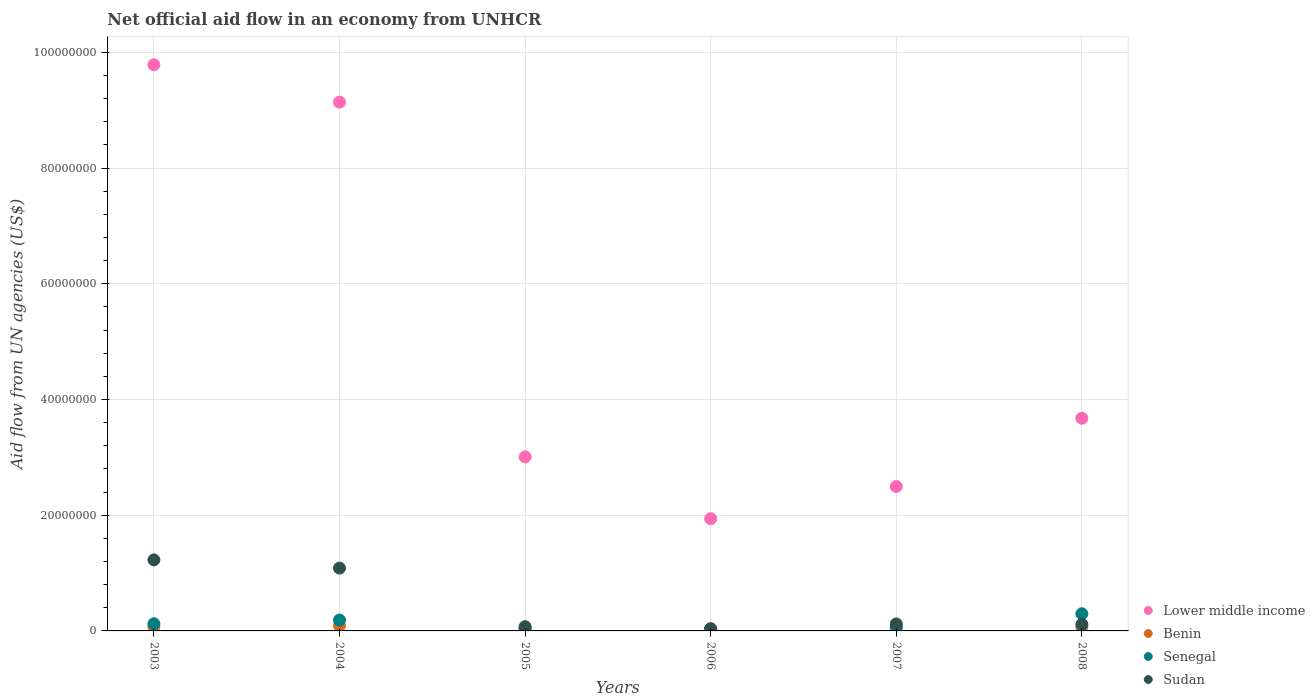What is the net official aid flow in Benin in 2006?
Ensure brevity in your answer.  3.20e+05. Across all years, what is the maximum net official aid flow in Benin?
Your answer should be compact. 9.00e+05. Across all years, what is the minimum net official aid flow in Senegal?
Provide a short and direct response. 2.60e+05. In which year was the net official aid flow in Benin maximum?
Offer a terse response. 2004. What is the total net official aid flow in Sudan in the graph?
Make the answer very short. 2.66e+07. What is the difference between the net official aid flow in Sudan in 2006 and the net official aid flow in Senegal in 2003?
Provide a succinct answer. -8.60e+05. What is the average net official aid flow in Lower middle income per year?
Your response must be concise. 5.01e+07. In the year 2005, what is the difference between the net official aid flow in Senegal and net official aid flow in Sudan?
Give a very brief answer. -2.30e+05. What is the ratio of the net official aid flow in Sudan in 2003 to that in 2006?
Ensure brevity in your answer.  32.32. What is the difference between the highest and the second highest net official aid flow in Lower middle income?
Make the answer very short. 6.45e+06. What is the difference between the highest and the lowest net official aid flow in Benin?
Offer a terse response. 5.80e+05. In how many years, is the net official aid flow in Senegal greater than the average net official aid flow in Senegal taken over all years?
Your answer should be very brief. 2. Is it the case that in every year, the sum of the net official aid flow in Sudan and net official aid flow in Benin  is greater than the sum of net official aid flow in Lower middle income and net official aid flow in Senegal?
Provide a succinct answer. No. Is it the case that in every year, the sum of the net official aid flow in Senegal and net official aid flow in Lower middle income  is greater than the net official aid flow in Benin?
Provide a succinct answer. Yes. Is the net official aid flow in Sudan strictly greater than the net official aid flow in Benin over the years?
Provide a succinct answer. Yes. How many dotlines are there?
Offer a terse response. 4. How many years are there in the graph?
Provide a succinct answer. 6. Are the values on the major ticks of Y-axis written in scientific E-notation?
Keep it short and to the point. No. Does the graph contain any zero values?
Keep it short and to the point. No. Does the graph contain grids?
Offer a very short reply. Yes. Where does the legend appear in the graph?
Offer a very short reply. Bottom right. How many legend labels are there?
Offer a very short reply. 4. What is the title of the graph?
Your answer should be very brief. Net official aid flow in an economy from UNHCR. Does "Malta" appear as one of the legend labels in the graph?
Offer a terse response. No. What is the label or title of the X-axis?
Your answer should be compact. Years. What is the label or title of the Y-axis?
Your answer should be very brief. Aid flow from UN agencies (US$). What is the Aid flow from UN agencies (US$) of Lower middle income in 2003?
Your answer should be very brief. 9.78e+07. What is the Aid flow from UN agencies (US$) of Benin in 2003?
Offer a terse response. 7.50e+05. What is the Aid flow from UN agencies (US$) of Senegal in 2003?
Give a very brief answer. 1.24e+06. What is the Aid flow from UN agencies (US$) of Sudan in 2003?
Make the answer very short. 1.23e+07. What is the Aid flow from UN agencies (US$) in Lower middle income in 2004?
Your answer should be very brief. 9.14e+07. What is the Aid flow from UN agencies (US$) of Senegal in 2004?
Offer a terse response. 1.88e+06. What is the Aid flow from UN agencies (US$) in Sudan in 2004?
Your response must be concise. 1.09e+07. What is the Aid flow from UN agencies (US$) of Lower middle income in 2005?
Make the answer very short. 3.01e+07. What is the Aid flow from UN agencies (US$) of Benin in 2005?
Your response must be concise. 4.30e+05. What is the Aid flow from UN agencies (US$) in Sudan in 2005?
Offer a terse response. 7.30e+05. What is the Aid flow from UN agencies (US$) in Lower middle income in 2006?
Offer a very short reply. 1.94e+07. What is the Aid flow from UN agencies (US$) in Senegal in 2006?
Offer a very short reply. 2.60e+05. What is the Aid flow from UN agencies (US$) in Sudan in 2006?
Provide a short and direct response. 3.80e+05. What is the Aid flow from UN agencies (US$) of Lower middle income in 2007?
Give a very brief answer. 2.50e+07. What is the Aid flow from UN agencies (US$) in Benin in 2007?
Give a very brief answer. 5.80e+05. What is the Aid flow from UN agencies (US$) of Senegal in 2007?
Offer a terse response. 7.00e+05. What is the Aid flow from UN agencies (US$) of Sudan in 2007?
Your answer should be compact. 1.21e+06. What is the Aid flow from UN agencies (US$) of Lower middle income in 2008?
Provide a succinct answer. 3.68e+07. What is the Aid flow from UN agencies (US$) of Benin in 2008?
Your answer should be very brief. 7.40e+05. What is the Aid flow from UN agencies (US$) of Senegal in 2008?
Keep it short and to the point. 2.97e+06. What is the Aid flow from UN agencies (US$) of Sudan in 2008?
Keep it short and to the point. 1.14e+06. Across all years, what is the maximum Aid flow from UN agencies (US$) of Lower middle income?
Offer a terse response. 9.78e+07. Across all years, what is the maximum Aid flow from UN agencies (US$) in Benin?
Keep it short and to the point. 9.00e+05. Across all years, what is the maximum Aid flow from UN agencies (US$) of Senegal?
Your answer should be compact. 2.97e+06. Across all years, what is the maximum Aid flow from UN agencies (US$) in Sudan?
Make the answer very short. 1.23e+07. Across all years, what is the minimum Aid flow from UN agencies (US$) of Lower middle income?
Keep it short and to the point. 1.94e+07. Across all years, what is the minimum Aid flow from UN agencies (US$) in Benin?
Ensure brevity in your answer.  3.20e+05. Across all years, what is the minimum Aid flow from UN agencies (US$) in Senegal?
Give a very brief answer. 2.60e+05. What is the total Aid flow from UN agencies (US$) of Lower middle income in the graph?
Your response must be concise. 3.00e+08. What is the total Aid flow from UN agencies (US$) of Benin in the graph?
Offer a very short reply. 3.72e+06. What is the total Aid flow from UN agencies (US$) of Senegal in the graph?
Provide a short and direct response. 7.55e+06. What is the total Aid flow from UN agencies (US$) of Sudan in the graph?
Make the answer very short. 2.66e+07. What is the difference between the Aid flow from UN agencies (US$) of Lower middle income in 2003 and that in 2004?
Your response must be concise. 6.45e+06. What is the difference between the Aid flow from UN agencies (US$) in Senegal in 2003 and that in 2004?
Your response must be concise. -6.40e+05. What is the difference between the Aid flow from UN agencies (US$) of Sudan in 2003 and that in 2004?
Offer a terse response. 1.42e+06. What is the difference between the Aid flow from UN agencies (US$) in Lower middle income in 2003 and that in 2005?
Provide a succinct answer. 6.78e+07. What is the difference between the Aid flow from UN agencies (US$) of Benin in 2003 and that in 2005?
Your answer should be compact. 3.20e+05. What is the difference between the Aid flow from UN agencies (US$) in Senegal in 2003 and that in 2005?
Your response must be concise. 7.40e+05. What is the difference between the Aid flow from UN agencies (US$) in Sudan in 2003 and that in 2005?
Your answer should be very brief. 1.16e+07. What is the difference between the Aid flow from UN agencies (US$) in Lower middle income in 2003 and that in 2006?
Make the answer very short. 7.84e+07. What is the difference between the Aid flow from UN agencies (US$) of Benin in 2003 and that in 2006?
Make the answer very short. 4.30e+05. What is the difference between the Aid flow from UN agencies (US$) in Senegal in 2003 and that in 2006?
Make the answer very short. 9.80e+05. What is the difference between the Aid flow from UN agencies (US$) in Sudan in 2003 and that in 2006?
Keep it short and to the point. 1.19e+07. What is the difference between the Aid flow from UN agencies (US$) of Lower middle income in 2003 and that in 2007?
Your answer should be compact. 7.29e+07. What is the difference between the Aid flow from UN agencies (US$) of Benin in 2003 and that in 2007?
Keep it short and to the point. 1.70e+05. What is the difference between the Aid flow from UN agencies (US$) in Senegal in 2003 and that in 2007?
Your response must be concise. 5.40e+05. What is the difference between the Aid flow from UN agencies (US$) in Sudan in 2003 and that in 2007?
Your answer should be very brief. 1.11e+07. What is the difference between the Aid flow from UN agencies (US$) in Lower middle income in 2003 and that in 2008?
Provide a succinct answer. 6.11e+07. What is the difference between the Aid flow from UN agencies (US$) of Benin in 2003 and that in 2008?
Make the answer very short. 10000. What is the difference between the Aid flow from UN agencies (US$) of Senegal in 2003 and that in 2008?
Offer a very short reply. -1.73e+06. What is the difference between the Aid flow from UN agencies (US$) of Sudan in 2003 and that in 2008?
Ensure brevity in your answer.  1.11e+07. What is the difference between the Aid flow from UN agencies (US$) of Lower middle income in 2004 and that in 2005?
Your answer should be very brief. 6.13e+07. What is the difference between the Aid flow from UN agencies (US$) in Benin in 2004 and that in 2005?
Give a very brief answer. 4.70e+05. What is the difference between the Aid flow from UN agencies (US$) of Senegal in 2004 and that in 2005?
Provide a short and direct response. 1.38e+06. What is the difference between the Aid flow from UN agencies (US$) in Sudan in 2004 and that in 2005?
Keep it short and to the point. 1.01e+07. What is the difference between the Aid flow from UN agencies (US$) in Lower middle income in 2004 and that in 2006?
Your response must be concise. 7.20e+07. What is the difference between the Aid flow from UN agencies (US$) of Benin in 2004 and that in 2006?
Provide a short and direct response. 5.80e+05. What is the difference between the Aid flow from UN agencies (US$) in Senegal in 2004 and that in 2006?
Ensure brevity in your answer.  1.62e+06. What is the difference between the Aid flow from UN agencies (US$) of Sudan in 2004 and that in 2006?
Your answer should be compact. 1.05e+07. What is the difference between the Aid flow from UN agencies (US$) in Lower middle income in 2004 and that in 2007?
Your response must be concise. 6.64e+07. What is the difference between the Aid flow from UN agencies (US$) in Senegal in 2004 and that in 2007?
Your answer should be compact. 1.18e+06. What is the difference between the Aid flow from UN agencies (US$) in Sudan in 2004 and that in 2007?
Offer a terse response. 9.65e+06. What is the difference between the Aid flow from UN agencies (US$) of Lower middle income in 2004 and that in 2008?
Give a very brief answer. 5.46e+07. What is the difference between the Aid flow from UN agencies (US$) in Senegal in 2004 and that in 2008?
Offer a terse response. -1.09e+06. What is the difference between the Aid flow from UN agencies (US$) in Sudan in 2004 and that in 2008?
Provide a short and direct response. 9.72e+06. What is the difference between the Aid flow from UN agencies (US$) of Lower middle income in 2005 and that in 2006?
Offer a terse response. 1.07e+07. What is the difference between the Aid flow from UN agencies (US$) of Benin in 2005 and that in 2006?
Your answer should be compact. 1.10e+05. What is the difference between the Aid flow from UN agencies (US$) in Lower middle income in 2005 and that in 2007?
Make the answer very short. 5.13e+06. What is the difference between the Aid flow from UN agencies (US$) in Benin in 2005 and that in 2007?
Provide a succinct answer. -1.50e+05. What is the difference between the Aid flow from UN agencies (US$) of Senegal in 2005 and that in 2007?
Provide a succinct answer. -2.00e+05. What is the difference between the Aid flow from UN agencies (US$) in Sudan in 2005 and that in 2007?
Your answer should be compact. -4.80e+05. What is the difference between the Aid flow from UN agencies (US$) in Lower middle income in 2005 and that in 2008?
Your response must be concise. -6.67e+06. What is the difference between the Aid flow from UN agencies (US$) of Benin in 2005 and that in 2008?
Your response must be concise. -3.10e+05. What is the difference between the Aid flow from UN agencies (US$) of Senegal in 2005 and that in 2008?
Offer a very short reply. -2.47e+06. What is the difference between the Aid flow from UN agencies (US$) in Sudan in 2005 and that in 2008?
Your answer should be compact. -4.10e+05. What is the difference between the Aid flow from UN agencies (US$) in Lower middle income in 2006 and that in 2007?
Your response must be concise. -5.56e+06. What is the difference between the Aid flow from UN agencies (US$) of Senegal in 2006 and that in 2007?
Offer a very short reply. -4.40e+05. What is the difference between the Aid flow from UN agencies (US$) of Sudan in 2006 and that in 2007?
Your response must be concise. -8.30e+05. What is the difference between the Aid flow from UN agencies (US$) of Lower middle income in 2006 and that in 2008?
Your response must be concise. -1.74e+07. What is the difference between the Aid flow from UN agencies (US$) of Benin in 2006 and that in 2008?
Make the answer very short. -4.20e+05. What is the difference between the Aid flow from UN agencies (US$) in Senegal in 2006 and that in 2008?
Your answer should be compact. -2.71e+06. What is the difference between the Aid flow from UN agencies (US$) of Sudan in 2006 and that in 2008?
Offer a very short reply. -7.60e+05. What is the difference between the Aid flow from UN agencies (US$) in Lower middle income in 2007 and that in 2008?
Provide a succinct answer. -1.18e+07. What is the difference between the Aid flow from UN agencies (US$) in Senegal in 2007 and that in 2008?
Make the answer very short. -2.27e+06. What is the difference between the Aid flow from UN agencies (US$) of Sudan in 2007 and that in 2008?
Ensure brevity in your answer.  7.00e+04. What is the difference between the Aid flow from UN agencies (US$) in Lower middle income in 2003 and the Aid flow from UN agencies (US$) in Benin in 2004?
Offer a terse response. 9.70e+07. What is the difference between the Aid flow from UN agencies (US$) in Lower middle income in 2003 and the Aid flow from UN agencies (US$) in Senegal in 2004?
Offer a very short reply. 9.60e+07. What is the difference between the Aid flow from UN agencies (US$) of Lower middle income in 2003 and the Aid flow from UN agencies (US$) of Sudan in 2004?
Offer a very short reply. 8.70e+07. What is the difference between the Aid flow from UN agencies (US$) of Benin in 2003 and the Aid flow from UN agencies (US$) of Senegal in 2004?
Your response must be concise. -1.13e+06. What is the difference between the Aid flow from UN agencies (US$) in Benin in 2003 and the Aid flow from UN agencies (US$) in Sudan in 2004?
Provide a succinct answer. -1.01e+07. What is the difference between the Aid flow from UN agencies (US$) of Senegal in 2003 and the Aid flow from UN agencies (US$) of Sudan in 2004?
Your answer should be very brief. -9.62e+06. What is the difference between the Aid flow from UN agencies (US$) of Lower middle income in 2003 and the Aid flow from UN agencies (US$) of Benin in 2005?
Ensure brevity in your answer.  9.74e+07. What is the difference between the Aid flow from UN agencies (US$) in Lower middle income in 2003 and the Aid flow from UN agencies (US$) in Senegal in 2005?
Give a very brief answer. 9.74e+07. What is the difference between the Aid flow from UN agencies (US$) in Lower middle income in 2003 and the Aid flow from UN agencies (US$) in Sudan in 2005?
Ensure brevity in your answer.  9.71e+07. What is the difference between the Aid flow from UN agencies (US$) of Benin in 2003 and the Aid flow from UN agencies (US$) of Senegal in 2005?
Make the answer very short. 2.50e+05. What is the difference between the Aid flow from UN agencies (US$) of Senegal in 2003 and the Aid flow from UN agencies (US$) of Sudan in 2005?
Make the answer very short. 5.10e+05. What is the difference between the Aid flow from UN agencies (US$) in Lower middle income in 2003 and the Aid flow from UN agencies (US$) in Benin in 2006?
Ensure brevity in your answer.  9.75e+07. What is the difference between the Aid flow from UN agencies (US$) of Lower middle income in 2003 and the Aid flow from UN agencies (US$) of Senegal in 2006?
Make the answer very short. 9.76e+07. What is the difference between the Aid flow from UN agencies (US$) of Lower middle income in 2003 and the Aid flow from UN agencies (US$) of Sudan in 2006?
Provide a succinct answer. 9.75e+07. What is the difference between the Aid flow from UN agencies (US$) of Benin in 2003 and the Aid flow from UN agencies (US$) of Senegal in 2006?
Give a very brief answer. 4.90e+05. What is the difference between the Aid flow from UN agencies (US$) in Benin in 2003 and the Aid flow from UN agencies (US$) in Sudan in 2006?
Provide a succinct answer. 3.70e+05. What is the difference between the Aid flow from UN agencies (US$) of Senegal in 2003 and the Aid flow from UN agencies (US$) of Sudan in 2006?
Provide a succinct answer. 8.60e+05. What is the difference between the Aid flow from UN agencies (US$) of Lower middle income in 2003 and the Aid flow from UN agencies (US$) of Benin in 2007?
Your answer should be compact. 9.73e+07. What is the difference between the Aid flow from UN agencies (US$) of Lower middle income in 2003 and the Aid flow from UN agencies (US$) of Senegal in 2007?
Provide a succinct answer. 9.72e+07. What is the difference between the Aid flow from UN agencies (US$) of Lower middle income in 2003 and the Aid flow from UN agencies (US$) of Sudan in 2007?
Your response must be concise. 9.66e+07. What is the difference between the Aid flow from UN agencies (US$) in Benin in 2003 and the Aid flow from UN agencies (US$) in Sudan in 2007?
Make the answer very short. -4.60e+05. What is the difference between the Aid flow from UN agencies (US$) of Senegal in 2003 and the Aid flow from UN agencies (US$) of Sudan in 2007?
Your answer should be compact. 3.00e+04. What is the difference between the Aid flow from UN agencies (US$) of Lower middle income in 2003 and the Aid flow from UN agencies (US$) of Benin in 2008?
Give a very brief answer. 9.71e+07. What is the difference between the Aid flow from UN agencies (US$) of Lower middle income in 2003 and the Aid flow from UN agencies (US$) of Senegal in 2008?
Ensure brevity in your answer.  9.49e+07. What is the difference between the Aid flow from UN agencies (US$) of Lower middle income in 2003 and the Aid flow from UN agencies (US$) of Sudan in 2008?
Make the answer very short. 9.67e+07. What is the difference between the Aid flow from UN agencies (US$) of Benin in 2003 and the Aid flow from UN agencies (US$) of Senegal in 2008?
Offer a terse response. -2.22e+06. What is the difference between the Aid flow from UN agencies (US$) of Benin in 2003 and the Aid flow from UN agencies (US$) of Sudan in 2008?
Your response must be concise. -3.90e+05. What is the difference between the Aid flow from UN agencies (US$) of Senegal in 2003 and the Aid flow from UN agencies (US$) of Sudan in 2008?
Your response must be concise. 1.00e+05. What is the difference between the Aid flow from UN agencies (US$) of Lower middle income in 2004 and the Aid flow from UN agencies (US$) of Benin in 2005?
Your answer should be very brief. 9.10e+07. What is the difference between the Aid flow from UN agencies (US$) of Lower middle income in 2004 and the Aid flow from UN agencies (US$) of Senegal in 2005?
Keep it short and to the point. 9.09e+07. What is the difference between the Aid flow from UN agencies (US$) of Lower middle income in 2004 and the Aid flow from UN agencies (US$) of Sudan in 2005?
Give a very brief answer. 9.07e+07. What is the difference between the Aid flow from UN agencies (US$) of Benin in 2004 and the Aid flow from UN agencies (US$) of Sudan in 2005?
Provide a succinct answer. 1.70e+05. What is the difference between the Aid flow from UN agencies (US$) in Senegal in 2004 and the Aid flow from UN agencies (US$) in Sudan in 2005?
Your response must be concise. 1.15e+06. What is the difference between the Aid flow from UN agencies (US$) of Lower middle income in 2004 and the Aid flow from UN agencies (US$) of Benin in 2006?
Your answer should be very brief. 9.11e+07. What is the difference between the Aid flow from UN agencies (US$) in Lower middle income in 2004 and the Aid flow from UN agencies (US$) in Senegal in 2006?
Ensure brevity in your answer.  9.11e+07. What is the difference between the Aid flow from UN agencies (US$) of Lower middle income in 2004 and the Aid flow from UN agencies (US$) of Sudan in 2006?
Provide a succinct answer. 9.10e+07. What is the difference between the Aid flow from UN agencies (US$) of Benin in 2004 and the Aid flow from UN agencies (US$) of Senegal in 2006?
Your response must be concise. 6.40e+05. What is the difference between the Aid flow from UN agencies (US$) of Benin in 2004 and the Aid flow from UN agencies (US$) of Sudan in 2006?
Your answer should be very brief. 5.20e+05. What is the difference between the Aid flow from UN agencies (US$) of Senegal in 2004 and the Aid flow from UN agencies (US$) of Sudan in 2006?
Provide a succinct answer. 1.50e+06. What is the difference between the Aid flow from UN agencies (US$) in Lower middle income in 2004 and the Aid flow from UN agencies (US$) in Benin in 2007?
Offer a terse response. 9.08e+07. What is the difference between the Aid flow from UN agencies (US$) of Lower middle income in 2004 and the Aid flow from UN agencies (US$) of Senegal in 2007?
Provide a succinct answer. 9.07e+07. What is the difference between the Aid flow from UN agencies (US$) in Lower middle income in 2004 and the Aid flow from UN agencies (US$) in Sudan in 2007?
Keep it short and to the point. 9.02e+07. What is the difference between the Aid flow from UN agencies (US$) in Benin in 2004 and the Aid flow from UN agencies (US$) in Senegal in 2007?
Make the answer very short. 2.00e+05. What is the difference between the Aid flow from UN agencies (US$) in Benin in 2004 and the Aid flow from UN agencies (US$) in Sudan in 2007?
Your answer should be compact. -3.10e+05. What is the difference between the Aid flow from UN agencies (US$) of Senegal in 2004 and the Aid flow from UN agencies (US$) of Sudan in 2007?
Your answer should be compact. 6.70e+05. What is the difference between the Aid flow from UN agencies (US$) in Lower middle income in 2004 and the Aid flow from UN agencies (US$) in Benin in 2008?
Provide a succinct answer. 9.07e+07. What is the difference between the Aid flow from UN agencies (US$) of Lower middle income in 2004 and the Aid flow from UN agencies (US$) of Senegal in 2008?
Keep it short and to the point. 8.84e+07. What is the difference between the Aid flow from UN agencies (US$) in Lower middle income in 2004 and the Aid flow from UN agencies (US$) in Sudan in 2008?
Keep it short and to the point. 9.03e+07. What is the difference between the Aid flow from UN agencies (US$) of Benin in 2004 and the Aid flow from UN agencies (US$) of Senegal in 2008?
Offer a terse response. -2.07e+06. What is the difference between the Aid flow from UN agencies (US$) in Benin in 2004 and the Aid flow from UN agencies (US$) in Sudan in 2008?
Provide a short and direct response. -2.40e+05. What is the difference between the Aid flow from UN agencies (US$) in Senegal in 2004 and the Aid flow from UN agencies (US$) in Sudan in 2008?
Offer a very short reply. 7.40e+05. What is the difference between the Aid flow from UN agencies (US$) of Lower middle income in 2005 and the Aid flow from UN agencies (US$) of Benin in 2006?
Your answer should be compact. 2.98e+07. What is the difference between the Aid flow from UN agencies (US$) in Lower middle income in 2005 and the Aid flow from UN agencies (US$) in Senegal in 2006?
Give a very brief answer. 2.98e+07. What is the difference between the Aid flow from UN agencies (US$) of Lower middle income in 2005 and the Aid flow from UN agencies (US$) of Sudan in 2006?
Your response must be concise. 2.97e+07. What is the difference between the Aid flow from UN agencies (US$) of Benin in 2005 and the Aid flow from UN agencies (US$) of Sudan in 2006?
Your answer should be compact. 5.00e+04. What is the difference between the Aid flow from UN agencies (US$) in Lower middle income in 2005 and the Aid flow from UN agencies (US$) in Benin in 2007?
Provide a short and direct response. 2.95e+07. What is the difference between the Aid flow from UN agencies (US$) in Lower middle income in 2005 and the Aid flow from UN agencies (US$) in Senegal in 2007?
Your response must be concise. 2.94e+07. What is the difference between the Aid flow from UN agencies (US$) in Lower middle income in 2005 and the Aid flow from UN agencies (US$) in Sudan in 2007?
Your answer should be very brief. 2.89e+07. What is the difference between the Aid flow from UN agencies (US$) in Benin in 2005 and the Aid flow from UN agencies (US$) in Sudan in 2007?
Offer a terse response. -7.80e+05. What is the difference between the Aid flow from UN agencies (US$) in Senegal in 2005 and the Aid flow from UN agencies (US$) in Sudan in 2007?
Provide a short and direct response. -7.10e+05. What is the difference between the Aid flow from UN agencies (US$) of Lower middle income in 2005 and the Aid flow from UN agencies (US$) of Benin in 2008?
Offer a terse response. 2.94e+07. What is the difference between the Aid flow from UN agencies (US$) of Lower middle income in 2005 and the Aid flow from UN agencies (US$) of Senegal in 2008?
Offer a terse response. 2.71e+07. What is the difference between the Aid flow from UN agencies (US$) in Lower middle income in 2005 and the Aid flow from UN agencies (US$) in Sudan in 2008?
Your answer should be very brief. 2.90e+07. What is the difference between the Aid flow from UN agencies (US$) of Benin in 2005 and the Aid flow from UN agencies (US$) of Senegal in 2008?
Give a very brief answer. -2.54e+06. What is the difference between the Aid flow from UN agencies (US$) in Benin in 2005 and the Aid flow from UN agencies (US$) in Sudan in 2008?
Ensure brevity in your answer.  -7.10e+05. What is the difference between the Aid flow from UN agencies (US$) of Senegal in 2005 and the Aid flow from UN agencies (US$) of Sudan in 2008?
Your answer should be very brief. -6.40e+05. What is the difference between the Aid flow from UN agencies (US$) in Lower middle income in 2006 and the Aid flow from UN agencies (US$) in Benin in 2007?
Keep it short and to the point. 1.88e+07. What is the difference between the Aid flow from UN agencies (US$) in Lower middle income in 2006 and the Aid flow from UN agencies (US$) in Senegal in 2007?
Ensure brevity in your answer.  1.87e+07. What is the difference between the Aid flow from UN agencies (US$) in Lower middle income in 2006 and the Aid flow from UN agencies (US$) in Sudan in 2007?
Your answer should be compact. 1.82e+07. What is the difference between the Aid flow from UN agencies (US$) in Benin in 2006 and the Aid flow from UN agencies (US$) in Senegal in 2007?
Keep it short and to the point. -3.80e+05. What is the difference between the Aid flow from UN agencies (US$) in Benin in 2006 and the Aid flow from UN agencies (US$) in Sudan in 2007?
Offer a very short reply. -8.90e+05. What is the difference between the Aid flow from UN agencies (US$) of Senegal in 2006 and the Aid flow from UN agencies (US$) of Sudan in 2007?
Your response must be concise. -9.50e+05. What is the difference between the Aid flow from UN agencies (US$) of Lower middle income in 2006 and the Aid flow from UN agencies (US$) of Benin in 2008?
Give a very brief answer. 1.87e+07. What is the difference between the Aid flow from UN agencies (US$) in Lower middle income in 2006 and the Aid flow from UN agencies (US$) in Senegal in 2008?
Provide a short and direct response. 1.64e+07. What is the difference between the Aid flow from UN agencies (US$) in Lower middle income in 2006 and the Aid flow from UN agencies (US$) in Sudan in 2008?
Your answer should be very brief. 1.83e+07. What is the difference between the Aid flow from UN agencies (US$) of Benin in 2006 and the Aid flow from UN agencies (US$) of Senegal in 2008?
Give a very brief answer. -2.65e+06. What is the difference between the Aid flow from UN agencies (US$) of Benin in 2006 and the Aid flow from UN agencies (US$) of Sudan in 2008?
Your answer should be compact. -8.20e+05. What is the difference between the Aid flow from UN agencies (US$) in Senegal in 2006 and the Aid flow from UN agencies (US$) in Sudan in 2008?
Your answer should be compact. -8.80e+05. What is the difference between the Aid flow from UN agencies (US$) in Lower middle income in 2007 and the Aid flow from UN agencies (US$) in Benin in 2008?
Give a very brief answer. 2.42e+07. What is the difference between the Aid flow from UN agencies (US$) of Lower middle income in 2007 and the Aid flow from UN agencies (US$) of Senegal in 2008?
Provide a succinct answer. 2.20e+07. What is the difference between the Aid flow from UN agencies (US$) of Lower middle income in 2007 and the Aid flow from UN agencies (US$) of Sudan in 2008?
Offer a terse response. 2.38e+07. What is the difference between the Aid flow from UN agencies (US$) in Benin in 2007 and the Aid flow from UN agencies (US$) in Senegal in 2008?
Provide a succinct answer. -2.39e+06. What is the difference between the Aid flow from UN agencies (US$) in Benin in 2007 and the Aid flow from UN agencies (US$) in Sudan in 2008?
Make the answer very short. -5.60e+05. What is the difference between the Aid flow from UN agencies (US$) in Senegal in 2007 and the Aid flow from UN agencies (US$) in Sudan in 2008?
Offer a terse response. -4.40e+05. What is the average Aid flow from UN agencies (US$) in Lower middle income per year?
Your response must be concise. 5.01e+07. What is the average Aid flow from UN agencies (US$) of Benin per year?
Provide a succinct answer. 6.20e+05. What is the average Aid flow from UN agencies (US$) in Senegal per year?
Offer a terse response. 1.26e+06. What is the average Aid flow from UN agencies (US$) in Sudan per year?
Ensure brevity in your answer.  4.43e+06. In the year 2003, what is the difference between the Aid flow from UN agencies (US$) in Lower middle income and Aid flow from UN agencies (US$) in Benin?
Your response must be concise. 9.71e+07. In the year 2003, what is the difference between the Aid flow from UN agencies (US$) of Lower middle income and Aid flow from UN agencies (US$) of Senegal?
Your answer should be compact. 9.66e+07. In the year 2003, what is the difference between the Aid flow from UN agencies (US$) in Lower middle income and Aid flow from UN agencies (US$) in Sudan?
Offer a terse response. 8.56e+07. In the year 2003, what is the difference between the Aid flow from UN agencies (US$) of Benin and Aid flow from UN agencies (US$) of Senegal?
Your response must be concise. -4.90e+05. In the year 2003, what is the difference between the Aid flow from UN agencies (US$) of Benin and Aid flow from UN agencies (US$) of Sudan?
Offer a terse response. -1.15e+07. In the year 2003, what is the difference between the Aid flow from UN agencies (US$) in Senegal and Aid flow from UN agencies (US$) in Sudan?
Your response must be concise. -1.10e+07. In the year 2004, what is the difference between the Aid flow from UN agencies (US$) of Lower middle income and Aid flow from UN agencies (US$) of Benin?
Your response must be concise. 9.05e+07. In the year 2004, what is the difference between the Aid flow from UN agencies (US$) of Lower middle income and Aid flow from UN agencies (US$) of Senegal?
Make the answer very short. 8.95e+07. In the year 2004, what is the difference between the Aid flow from UN agencies (US$) in Lower middle income and Aid flow from UN agencies (US$) in Sudan?
Provide a succinct answer. 8.05e+07. In the year 2004, what is the difference between the Aid flow from UN agencies (US$) in Benin and Aid flow from UN agencies (US$) in Senegal?
Make the answer very short. -9.80e+05. In the year 2004, what is the difference between the Aid flow from UN agencies (US$) in Benin and Aid flow from UN agencies (US$) in Sudan?
Keep it short and to the point. -9.96e+06. In the year 2004, what is the difference between the Aid flow from UN agencies (US$) of Senegal and Aid flow from UN agencies (US$) of Sudan?
Provide a succinct answer. -8.98e+06. In the year 2005, what is the difference between the Aid flow from UN agencies (US$) in Lower middle income and Aid flow from UN agencies (US$) in Benin?
Offer a very short reply. 2.97e+07. In the year 2005, what is the difference between the Aid flow from UN agencies (US$) of Lower middle income and Aid flow from UN agencies (US$) of Senegal?
Your response must be concise. 2.96e+07. In the year 2005, what is the difference between the Aid flow from UN agencies (US$) of Lower middle income and Aid flow from UN agencies (US$) of Sudan?
Offer a terse response. 2.94e+07. In the year 2005, what is the difference between the Aid flow from UN agencies (US$) in Benin and Aid flow from UN agencies (US$) in Senegal?
Your answer should be compact. -7.00e+04. In the year 2005, what is the difference between the Aid flow from UN agencies (US$) in Benin and Aid flow from UN agencies (US$) in Sudan?
Give a very brief answer. -3.00e+05. In the year 2006, what is the difference between the Aid flow from UN agencies (US$) of Lower middle income and Aid flow from UN agencies (US$) of Benin?
Make the answer very short. 1.91e+07. In the year 2006, what is the difference between the Aid flow from UN agencies (US$) of Lower middle income and Aid flow from UN agencies (US$) of Senegal?
Your answer should be very brief. 1.91e+07. In the year 2006, what is the difference between the Aid flow from UN agencies (US$) of Lower middle income and Aid flow from UN agencies (US$) of Sudan?
Provide a short and direct response. 1.90e+07. In the year 2006, what is the difference between the Aid flow from UN agencies (US$) in Benin and Aid flow from UN agencies (US$) in Sudan?
Provide a succinct answer. -6.00e+04. In the year 2006, what is the difference between the Aid flow from UN agencies (US$) of Senegal and Aid flow from UN agencies (US$) of Sudan?
Your answer should be very brief. -1.20e+05. In the year 2007, what is the difference between the Aid flow from UN agencies (US$) of Lower middle income and Aid flow from UN agencies (US$) of Benin?
Offer a terse response. 2.44e+07. In the year 2007, what is the difference between the Aid flow from UN agencies (US$) in Lower middle income and Aid flow from UN agencies (US$) in Senegal?
Offer a very short reply. 2.43e+07. In the year 2007, what is the difference between the Aid flow from UN agencies (US$) of Lower middle income and Aid flow from UN agencies (US$) of Sudan?
Provide a succinct answer. 2.38e+07. In the year 2007, what is the difference between the Aid flow from UN agencies (US$) of Benin and Aid flow from UN agencies (US$) of Senegal?
Your response must be concise. -1.20e+05. In the year 2007, what is the difference between the Aid flow from UN agencies (US$) of Benin and Aid flow from UN agencies (US$) of Sudan?
Your answer should be compact. -6.30e+05. In the year 2007, what is the difference between the Aid flow from UN agencies (US$) of Senegal and Aid flow from UN agencies (US$) of Sudan?
Make the answer very short. -5.10e+05. In the year 2008, what is the difference between the Aid flow from UN agencies (US$) of Lower middle income and Aid flow from UN agencies (US$) of Benin?
Your answer should be compact. 3.60e+07. In the year 2008, what is the difference between the Aid flow from UN agencies (US$) of Lower middle income and Aid flow from UN agencies (US$) of Senegal?
Provide a succinct answer. 3.38e+07. In the year 2008, what is the difference between the Aid flow from UN agencies (US$) of Lower middle income and Aid flow from UN agencies (US$) of Sudan?
Your response must be concise. 3.56e+07. In the year 2008, what is the difference between the Aid flow from UN agencies (US$) in Benin and Aid flow from UN agencies (US$) in Senegal?
Ensure brevity in your answer.  -2.23e+06. In the year 2008, what is the difference between the Aid flow from UN agencies (US$) of Benin and Aid flow from UN agencies (US$) of Sudan?
Your response must be concise. -4.00e+05. In the year 2008, what is the difference between the Aid flow from UN agencies (US$) of Senegal and Aid flow from UN agencies (US$) of Sudan?
Keep it short and to the point. 1.83e+06. What is the ratio of the Aid flow from UN agencies (US$) in Lower middle income in 2003 to that in 2004?
Your answer should be very brief. 1.07. What is the ratio of the Aid flow from UN agencies (US$) of Benin in 2003 to that in 2004?
Offer a terse response. 0.83. What is the ratio of the Aid flow from UN agencies (US$) in Senegal in 2003 to that in 2004?
Your answer should be compact. 0.66. What is the ratio of the Aid flow from UN agencies (US$) of Sudan in 2003 to that in 2004?
Offer a very short reply. 1.13. What is the ratio of the Aid flow from UN agencies (US$) in Lower middle income in 2003 to that in 2005?
Your response must be concise. 3.25. What is the ratio of the Aid flow from UN agencies (US$) in Benin in 2003 to that in 2005?
Provide a short and direct response. 1.74. What is the ratio of the Aid flow from UN agencies (US$) in Senegal in 2003 to that in 2005?
Make the answer very short. 2.48. What is the ratio of the Aid flow from UN agencies (US$) of Sudan in 2003 to that in 2005?
Provide a succinct answer. 16.82. What is the ratio of the Aid flow from UN agencies (US$) in Lower middle income in 2003 to that in 2006?
Your response must be concise. 5.04. What is the ratio of the Aid flow from UN agencies (US$) in Benin in 2003 to that in 2006?
Offer a very short reply. 2.34. What is the ratio of the Aid flow from UN agencies (US$) of Senegal in 2003 to that in 2006?
Provide a succinct answer. 4.77. What is the ratio of the Aid flow from UN agencies (US$) of Sudan in 2003 to that in 2006?
Your response must be concise. 32.32. What is the ratio of the Aid flow from UN agencies (US$) in Lower middle income in 2003 to that in 2007?
Your answer should be very brief. 3.92. What is the ratio of the Aid flow from UN agencies (US$) in Benin in 2003 to that in 2007?
Your answer should be compact. 1.29. What is the ratio of the Aid flow from UN agencies (US$) in Senegal in 2003 to that in 2007?
Your answer should be compact. 1.77. What is the ratio of the Aid flow from UN agencies (US$) in Sudan in 2003 to that in 2007?
Provide a short and direct response. 10.15. What is the ratio of the Aid flow from UN agencies (US$) of Lower middle income in 2003 to that in 2008?
Keep it short and to the point. 2.66. What is the ratio of the Aid flow from UN agencies (US$) of Benin in 2003 to that in 2008?
Offer a very short reply. 1.01. What is the ratio of the Aid flow from UN agencies (US$) in Senegal in 2003 to that in 2008?
Your answer should be compact. 0.42. What is the ratio of the Aid flow from UN agencies (US$) of Sudan in 2003 to that in 2008?
Provide a succinct answer. 10.77. What is the ratio of the Aid flow from UN agencies (US$) of Lower middle income in 2004 to that in 2005?
Offer a very short reply. 3.04. What is the ratio of the Aid flow from UN agencies (US$) in Benin in 2004 to that in 2005?
Offer a terse response. 2.09. What is the ratio of the Aid flow from UN agencies (US$) of Senegal in 2004 to that in 2005?
Your answer should be compact. 3.76. What is the ratio of the Aid flow from UN agencies (US$) of Sudan in 2004 to that in 2005?
Give a very brief answer. 14.88. What is the ratio of the Aid flow from UN agencies (US$) of Lower middle income in 2004 to that in 2006?
Your response must be concise. 4.71. What is the ratio of the Aid flow from UN agencies (US$) in Benin in 2004 to that in 2006?
Provide a short and direct response. 2.81. What is the ratio of the Aid flow from UN agencies (US$) of Senegal in 2004 to that in 2006?
Your answer should be compact. 7.23. What is the ratio of the Aid flow from UN agencies (US$) of Sudan in 2004 to that in 2006?
Your answer should be very brief. 28.58. What is the ratio of the Aid flow from UN agencies (US$) of Lower middle income in 2004 to that in 2007?
Provide a short and direct response. 3.66. What is the ratio of the Aid flow from UN agencies (US$) of Benin in 2004 to that in 2007?
Keep it short and to the point. 1.55. What is the ratio of the Aid flow from UN agencies (US$) in Senegal in 2004 to that in 2007?
Give a very brief answer. 2.69. What is the ratio of the Aid flow from UN agencies (US$) in Sudan in 2004 to that in 2007?
Your answer should be very brief. 8.98. What is the ratio of the Aid flow from UN agencies (US$) of Lower middle income in 2004 to that in 2008?
Your response must be concise. 2.49. What is the ratio of the Aid flow from UN agencies (US$) of Benin in 2004 to that in 2008?
Provide a short and direct response. 1.22. What is the ratio of the Aid flow from UN agencies (US$) in Senegal in 2004 to that in 2008?
Ensure brevity in your answer.  0.63. What is the ratio of the Aid flow from UN agencies (US$) of Sudan in 2004 to that in 2008?
Your response must be concise. 9.53. What is the ratio of the Aid flow from UN agencies (US$) of Lower middle income in 2005 to that in 2006?
Offer a terse response. 1.55. What is the ratio of the Aid flow from UN agencies (US$) of Benin in 2005 to that in 2006?
Provide a short and direct response. 1.34. What is the ratio of the Aid flow from UN agencies (US$) of Senegal in 2005 to that in 2006?
Ensure brevity in your answer.  1.92. What is the ratio of the Aid flow from UN agencies (US$) of Sudan in 2005 to that in 2006?
Provide a succinct answer. 1.92. What is the ratio of the Aid flow from UN agencies (US$) of Lower middle income in 2005 to that in 2007?
Your response must be concise. 1.21. What is the ratio of the Aid flow from UN agencies (US$) of Benin in 2005 to that in 2007?
Give a very brief answer. 0.74. What is the ratio of the Aid flow from UN agencies (US$) in Sudan in 2005 to that in 2007?
Ensure brevity in your answer.  0.6. What is the ratio of the Aid flow from UN agencies (US$) of Lower middle income in 2005 to that in 2008?
Ensure brevity in your answer.  0.82. What is the ratio of the Aid flow from UN agencies (US$) in Benin in 2005 to that in 2008?
Offer a terse response. 0.58. What is the ratio of the Aid flow from UN agencies (US$) of Senegal in 2005 to that in 2008?
Keep it short and to the point. 0.17. What is the ratio of the Aid flow from UN agencies (US$) of Sudan in 2005 to that in 2008?
Your response must be concise. 0.64. What is the ratio of the Aid flow from UN agencies (US$) of Lower middle income in 2006 to that in 2007?
Offer a very short reply. 0.78. What is the ratio of the Aid flow from UN agencies (US$) of Benin in 2006 to that in 2007?
Give a very brief answer. 0.55. What is the ratio of the Aid flow from UN agencies (US$) in Senegal in 2006 to that in 2007?
Offer a terse response. 0.37. What is the ratio of the Aid flow from UN agencies (US$) in Sudan in 2006 to that in 2007?
Keep it short and to the point. 0.31. What is the ratio of the Aid flow from UN agencies (US$) of Lower middle income in 2006 to that in 2008?
Provide a succinct answer. 0.53. What is the ratio of the Aid flow from UN agencies (US$) in Benin in 2006 to that in 2008?
Offer a very short reply. 0.43. What is the ratio of the Aid flow from UN agencies (US$) in Senegal in 2006 to that in 2008?
Ensure brevity in your answer.  0.09. What is the ratio of the Aid flow from UN agencies (US$) of Lower middle income in 2007 to that in 2008?
Offer a terse response. 0.68. What is the ratio of the Aid flow from UN agencies (US$) in Benin in 2007 to that in 2008?
Provide a succinct answer. 0.78. What is the ratio of the Aid flow from UN agencies (US$) in Senegal in 2007 to that in 2008?
Provide a succinct answer. 0.24. What is the ratio of the Aid flow from UN agencies (US$) of Sudan in 2007 to that in 2008?
Provide a short and direct response. 1.06. What is the difference between the highest and the second highest Aid flow from UN agencies (US$) of Lower middle income?
Ensure brevity in your answer.  6.45e+06. What is the difference between the highest and the second highest Aid flow from UN agencies (US$) in Benin?
Offer a very short reply. 1.50e+05. What is the difference between the highest and the second highest Aid flow from UN agencies (US$) in Senegal?
Provide a short and direct response. 1.09e+06. What is the difference between the highest and the second highest Aid flow from UN agencies (US$) in Sudan?
Provide a short and direct response. 1.42e+06. What is the difference between the highest and the lowest Aid flow from UN agencies (US$) in Lower middle income?
Your answer should be very brief. 7.84e+07. What is the difference between the highest and the lowest Aid flow from UN agencies (US$) in Benin?
Your answer should be very brief. 5.80e+05. What is the difference between the highest and the lowest Aid flow from UN agencies (US$) of Senegal?
Provide a succinct answer. 2.71e+06. What is the difference between the highest and the lowest Aid flow from UN agencies (US$) of Sudan?
Your answer should be very brief. 1.19e+07. 